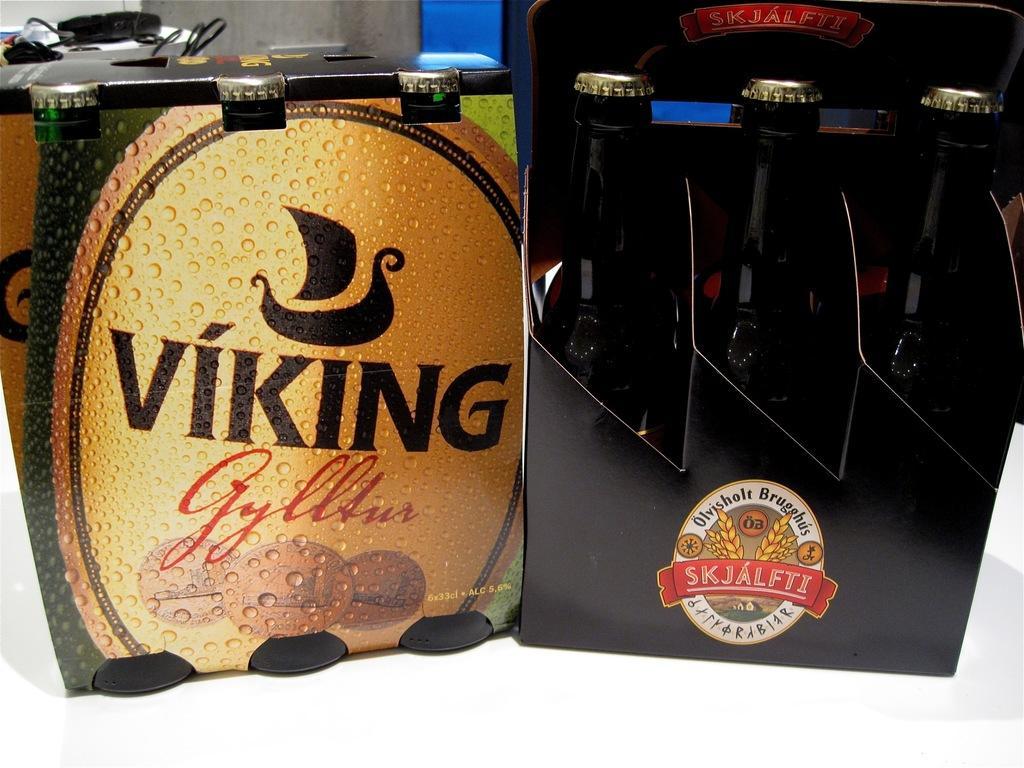How would you summarize this image in a sentence or two? In this picture we can see the boxes which contains bottles on the surface. At the top of the image we can see the wall, object and cables. 